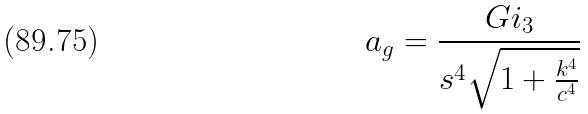Convert formula to latex. <formula><loc_0><loc_0><loc_500><loc_500>a _ { g } = \frac { G i _ { 3 } } { s ^ { 4 } \sqrt { 1 + \frac { k ^ { 4 } } { c ^ { 4 } } } }</formula> 